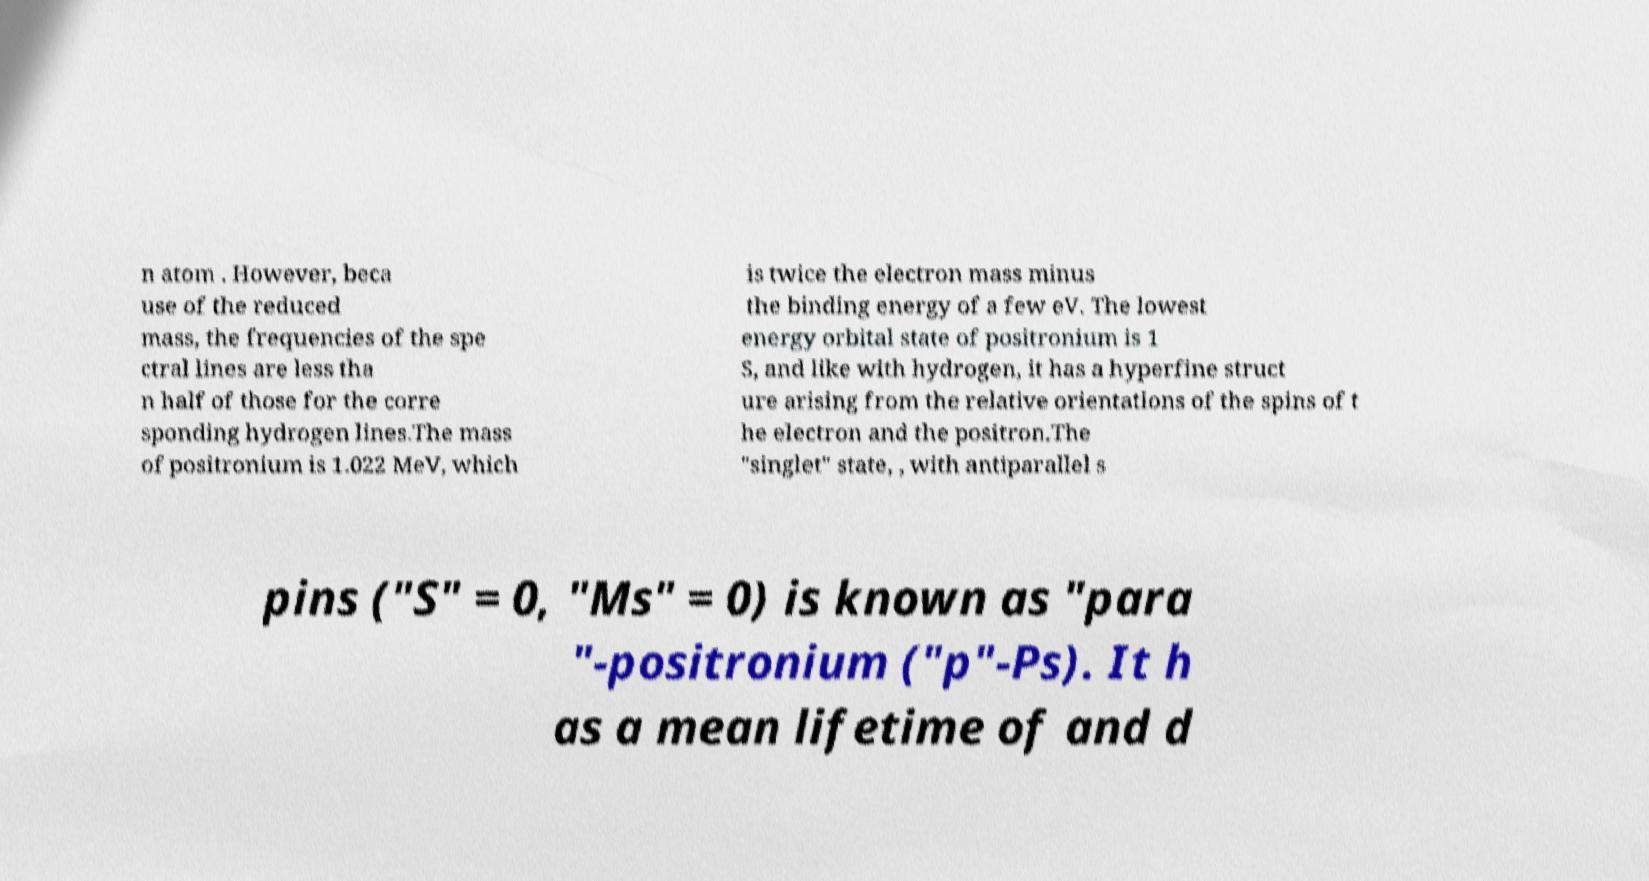Please read and relay the text visible in this image. What does it say? n atom . However, beca use of the reduced mass, the frequencies of the spe ctral lines are less tha n half of those for the corre sponding hydrogen lines.The mass of positronium is 1.022 MeV, which is twice the electron mass minus the binding energy of a few eV. The lowest energy orbital state of positronium is 1 S, and like with hydrogen, it has a hyperfine struct ure arising from the relative orientations of the spins of t he electron and the positron.The "singlet" state, , with antiparallel s pins ("S" = 0, "Ms" = 0) is known as "para "-positronium ("p"-Ps). It h as a mean lifetime of and d 